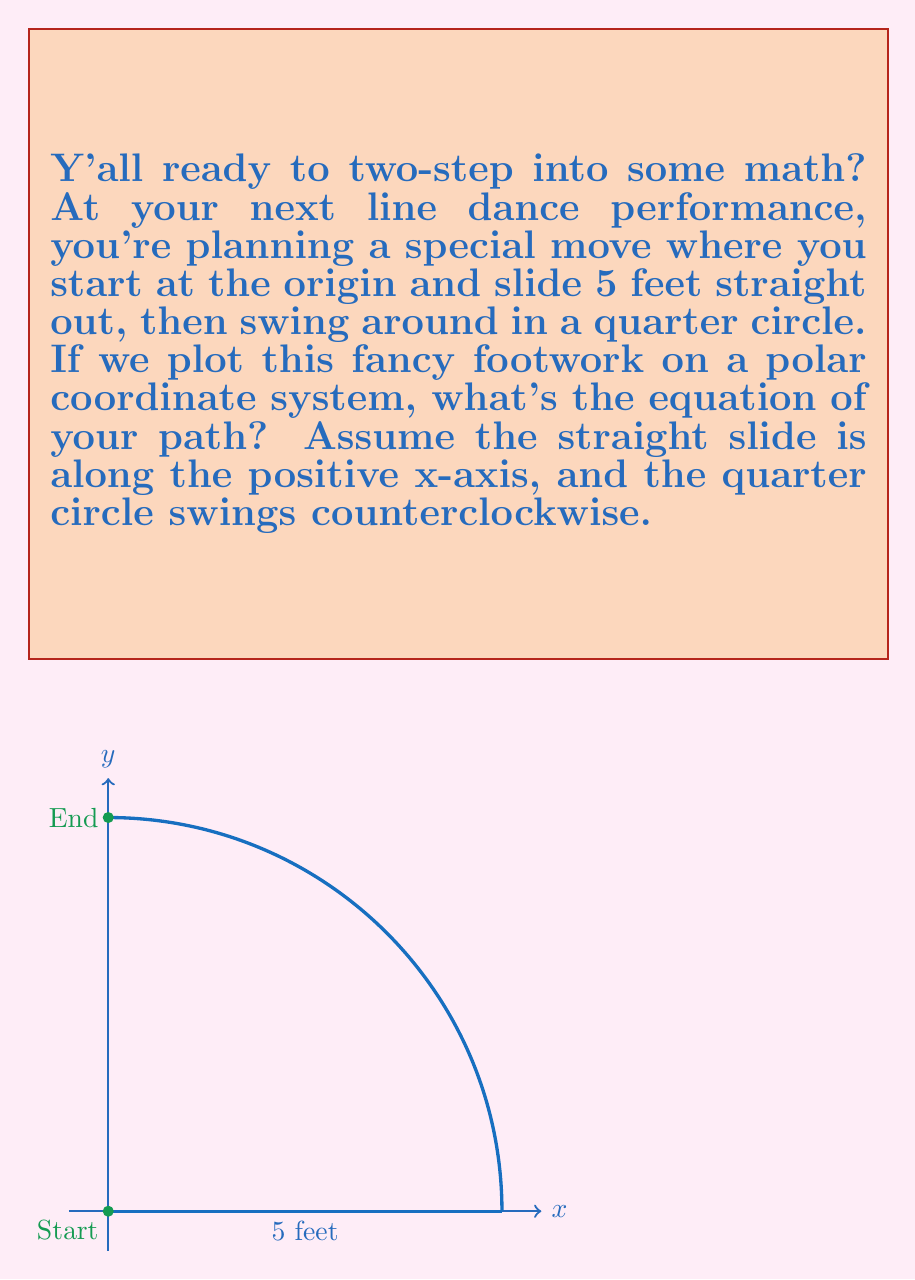Show me your answer to this math problem. Let's break this two-step into parts, partner:

1) The straight slide:
   - This is along the positive x-axis, from (0,0) to (5,0)
   - In polar coordinates, this is represented by $r = 5$ and $\theta = 0$

2) The quarter circle swing:
   - This is a circular arc from (5,0) to (0,5)
   - The equation of a circle centered at the origin is $r = 5$ (constant radius)
   - The angle $\theta$ varies from 0 to $\frac{\pi}{2}$ radians (90 degrees)

Now, to combine these moves into one equation:

$$r = \begin{cases} 
5, & \text{if } \theta = 0 \text{ (straight slide)} \\
5, & \text{if } 0 < \theta \leq \frac{\pi}{2} \text{ (quarter circle)}
\end{cases}$$

We can simplify this to a single equation:

$$r = 5, \quad 0 \leq \theta \leq \frac{\pi}{2}$$

This equation describes both parts of the move: the straight slide (when $\theta = 0$) and the quarter circle (when $0 < \theta \leq \frac{\pi}{2}$).
Answer: $r = 5, \quad 0 \leq \theta \leq \frac{\pi}{2}$ 